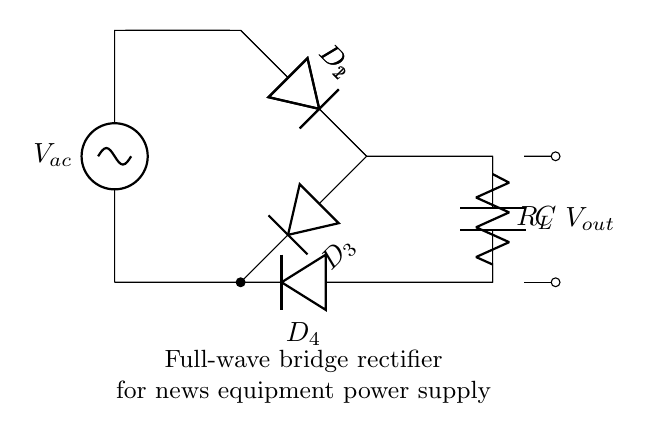What type of rectifier is represented in this diagram? The diagram shows a full-wave bridge rectifier, which is indicated by the arrangement of four diodes that allow both halves of the input AC waveform to be utilized.
Answer: full-wave bridge rectifier How many diodes are used in this circuit? The circuit clearly displays four diodes: D1, D2, D3, and D4, which are arranged in the bridge configuration to rectify the AC input.
Answer: four What is the purpose of the capacitor in this rectifier circuit? The capacitor, labeled C, acts as a filter to smooth out the output voltage, reducing fluctuations after rectification.
Answer: to smooth the output What is the label used for the AC voltage source? The AC voltage source is labeled as V_ac, which signifies that it provides the alternating current input to the rectifier circuit.
Answer: V_ac In this circuit, which component indicates the load? The resistor labeled R_L represents the load of the circuit, which consumes the power supplied by the rectifier.
Answer: R_L What is the output voltage node labeled as in the diagram? The output voltage is indicated by the label V_out, which shows where the rectified and smoothed voltage can be obtained for use in powered devices.
Answer: V_out What is the function of the diodes in this bridge rectifier? The diodes function to control the direction of current flow, only allowing current to pass in the forward direction, thus converting AC to DC.
Answer: to convert AC to DC 